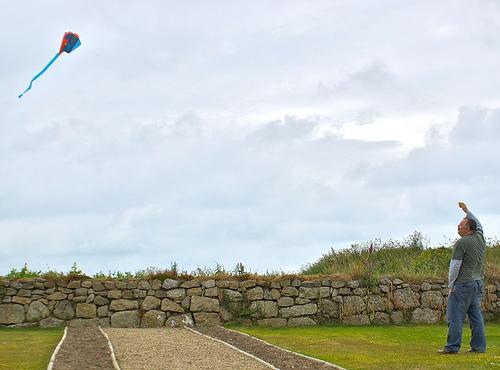Mention the main elements in the image and their colors. Man in green and white shirt and blue jeans flying a blue and red kite with a blue tail, green grass, a gray stone wall, and a light blue and white sky. How is the man holding his arm and what accessory is he handling? The man is holding his arm above his head, gripping the string of a blue-tailed, colorful kite flying in the sky. Provide a brief overview of the primary scene depicted in the image. A man holding onto a kite string, flying a colorful kite with a blue tail in a cloudy sky, near a short stone wall and grassy area. What are the main color contrasts in the image between the different elements? The contrast between the colorful kite and the cloudy sky, as well as between the green grass and gray stone wall. What are the main activities in the image and the background elements? Man flying a kite with a blue tail and a man with arm raised, against a background of grass, short stone wall, and cloud cover in the sky. What types of clothing is the man wearing and what is he doing in the image? The man is wearing a green and white shirt, blue jeans, and brown shoes, holding onto a kite string and flying a colorful kite. Briefly describe the man's posture and the surrounding environment. The man stands with his arm raised, surrounded by a grassy area, a short stone wall, and cloud cover in the sky. Write a brief sentence summarizing the overall content of the image. A man in casual clothing is flying a bright-colored kite against a backdrop of grass, stone wall, and a cloudy sky. Describe the atmosphere of the scene in relation to the weather and environment. A serene outdoor scene with a man flying a kite on a cloudy day near a grassy area and a gray stone wall. What are the primary and secondary colors present in the image? The primary colors are blue, red, green, and white; secondary colors include gray, brown, and light blue. 